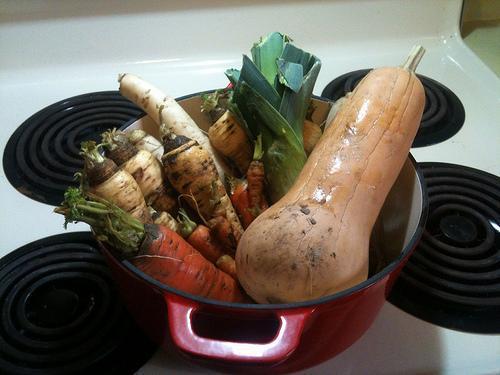How many pots are there?
Give a very brief answer. 1. 